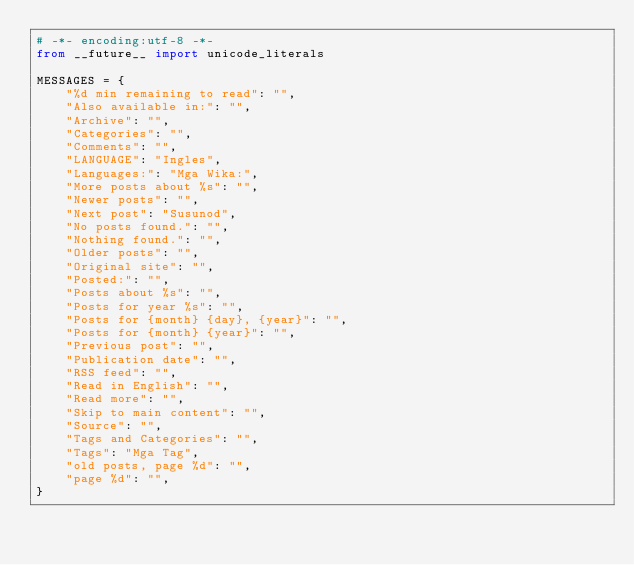Convert code to text. <code><loc_0><loc_0><loc_500><loc_500><_Python_># -*- encoding:utf-8 -*-
from __future__ import unicode_literals

MESSAGES = {
    "%d min remaining to read": "",
    "Also available in:": "",
    "Archive": "",
    "Categories": "",
    "Comments": "",
    "LANGUAGE": "Ingles",
    "Languages:": "Mga Wika:",
    "More posts about %s": "",
    "Newer posts": "",
    "Next post": "Susunod",
    "No posts found.": "",
    "Nothing found.": "",
    "Older posts": "",
    "Original site": "",
    "Posted:": "",
    "Posts about %s": "",
    "Posts for year %s": "",
    "Posts for {month} {day}, {year}": "",
    "Posts for {month} {year}": "",
    "Previous post": "",
    "Publication date": "",
    "RSS feed": "",
    "Read in English": "",
    "Read more": "",
    "Skip to main content": "",
    "Source": "",
    "Tags and Categories": "",
    "Tags": "Mga Tag",
    "old posts, page %d": "",
    "page %d": "",
}
</code> 